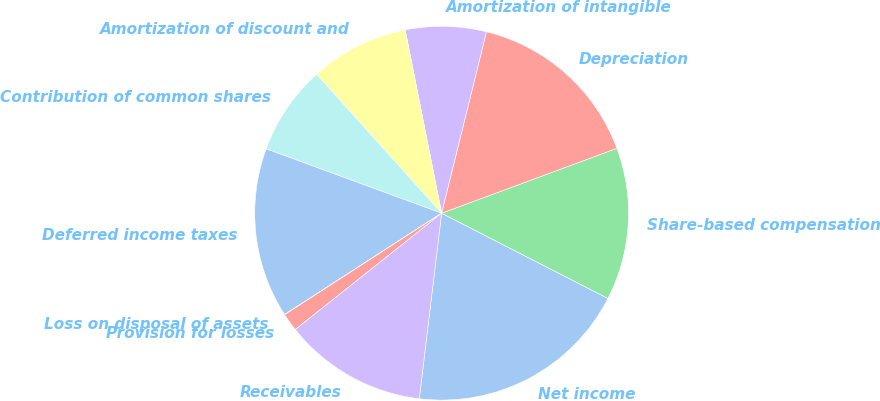<chart> <loc_0><loc_0><loc_500><loc_500><pie_chart><fcel>Net income<fcel>Share-based compensation<fcel>Depreciation<fcel>Amortization of intangible<fcel>Amortization of discount and<fcel>Contribution of common shares<fcel>Deferred income taxes<fcel>Loss on disposal of assets<fcel>Provision for losses<fcel>Receivables<nl><fcel>19.37%<fcel>13.18%<fcel>15.5%<fcel>6.98%<fcel>8.53%<fcel>7.75%<fcel>14.72%<fcel>0.01%<fcel>1.56%<fcel>12.4%<nl></chart> 